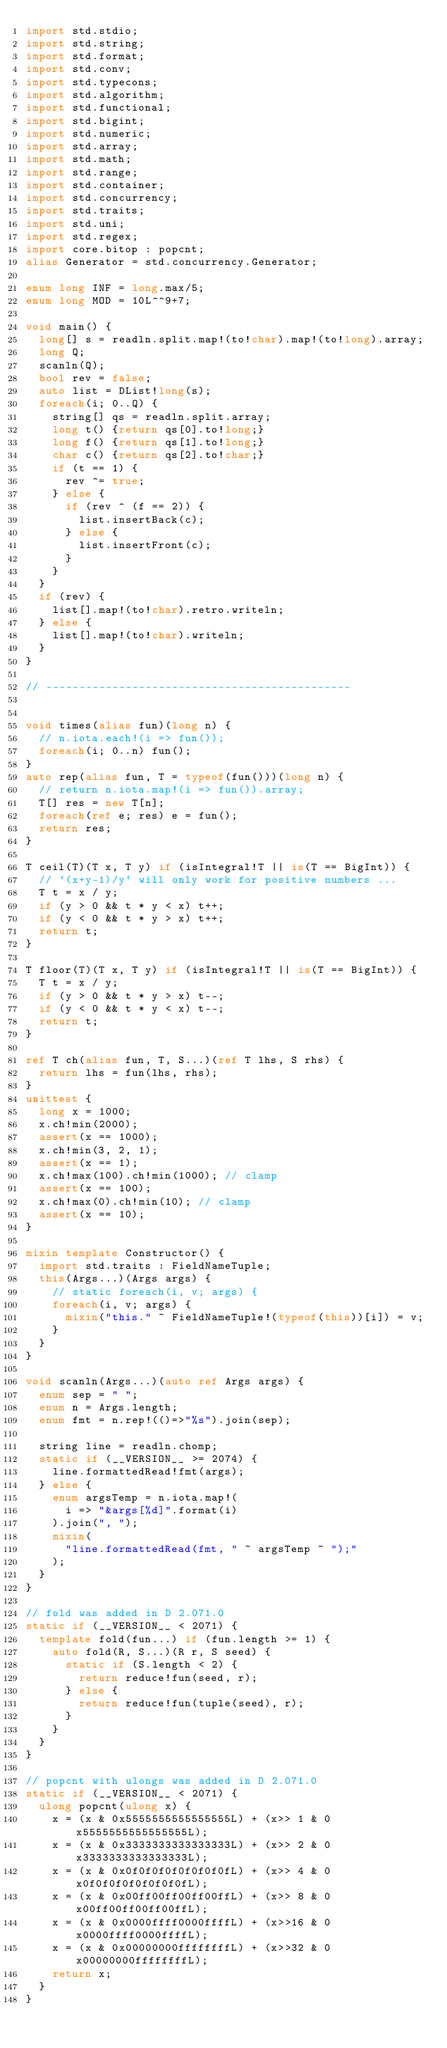<code> <loc_0><loc_0><loc_500><loc_500><_D_>import std.stdio;
import std.string;
import std.format;
import std.conv;
import std.typecons;
import std.algorithm;
import std.functional;
import std.bigint;
import std.numeric;
import std.array;
import std.math;
import std.range;
import std.container;
import std.concurrency;
import std.traits;
import std.uni;
import std.regex;
import core.bitop : popcnt;
alias Generator = std.concurrency.Generator;

enum long INF = long.max/5;
enum long MOD = 10L^^9+7;

void main() {
  long[] s = readln.split.map!(to!char).map!(to!long).array;
  long Q;
  scanln(Q);
  bool rev = false;
  auto list = DList!long(s);
  foreach(i; 0..Q) {
    string[] qs = readln.split.array;
    long t() {return qs[0].to!long;}
    long f() {return qs[1].to!long;}
    char c() {return qs[2].to!char;}
    if (t == 1) {
      rev ^= true;
    } else {
      if (rev ^ (f == 2)) {
        list.insertBack(c);
      } else {
        list.insertFront(c);
      }
    }
  }
  if (rev) {
    list[].map!(to!char).retro.writeln;
  } else {
    list[].map!(to!char).writeln;
  }
}

// ----------------------------------------------


void times(alias fun)(long n) {
  // n.iota.each!(i => fun());
  foreach(i; 0..n) fun();
}
auto rep(alias fun, T = typeof(fun()))(long n) {
  // return n.iota.map!(i => fun()).array;
  T[] res = new T[n];
  foreach(ref e; res) e = fun();
  return res;
}

T ceil(T)(T x, T y) if (isIntegral!T || is(T == BigInt)) {
  // `(x+y-1)/y` will only work for positive numbers ...
  T t = x / y;
  if (y > 0 && t * y < x) t++;
  if (y < 0 && t * y > x) t++;
  return t;
}

T floor(T)(T x, T y) if (isIntegral!T || is(T == BigInt)) {
  T t = x / y;
  if (y > 0 && t * y > x) t--;
  if (y < 0 && t * y < x) t--;
  return t;
}

ref T ch(alias fun, T, S...)(ref T lhs, S rhs) {
  return lhs = fun(lhs, rhs);
}
unittest {
  long x = 1000;
  x.ch!min(2000);
  assert(x == 1000);
  x.ch!min(3, 2, 1);
  assert(x == 1);
  x.ch!max(100).ch!min(1000); // clamp
  assert(x == 100);
  x.ch!max(0).ch!min(10); // clamp
  assert(x == 10);
}

mixin template Constructor() {
  import std.traits : FieldNameTuple;
  this(Args...)(Args args) {
    // static foreach(i, v; args) {
    foreach(i, v; args) {
      mixin("this." ~ FieldNameTuple!(typeof(this))[i]) = v;
    }
  }
}

void scanln(Args...)(auto ref Args args) {
  enum sep = " ";
  enum n = Args.length;
  enum fmt = n.rep!(()=>"%s").join(sep);

  string line = readln.chomp;
  static if (__VERSION__ >= 2074) {
    line.formattedRead!fmt(args);
  } else {
    enum argsTemp = n.iota.map!(
      i => "&args[%d]".format(i)
    ).join(", ");
    mixin(
      "line.formattedRead(fmt, " ~ argsTemp ~ ");"
    );
  }
}

// fold was added in D 2.071.0
static if (__VERSION__ < 2071) {
  template fold(fun...) if (fun.length >= 1) {
    auto fold(R, S...)(R r, S seed) {
      static if (S.length < 2) {
        return reduce!fun(seed, r);
      } else {
        return reduce!fun(tuple(seed), r);
      }
    }
  }
}

// popcnt with ulongs was added in D 2.071.0
static if (__VERSION__ < 2071) {
  ulong popcnt(ulong x) {
    x = (x & 0x5555555555555555L) + (x>> 1 & 0x5555555555555555L);
    x = (x & 0x3333333333333333L) + (x>> 2 & 0x3333333333333333L);
    x = (x & 0x0f0f0f0f0f0f0f0fL) + (x>> 4 & 0x0f0f0f0f0f0f0f0fL);
    x = (x & 0x00ff00ff00ff00ffL) + (x>> 8 & 0x00ff00ff00ff00ffL);
    x = (x & 0x0000ffff0000ffffL) + (x>>16 & 0x0000ffff0000ffffL);
    x = (x & 0x00000000ffffffffL) + (x>>32 & 0x00000000ffffffffL);
    return x;
  }
}
</code> 